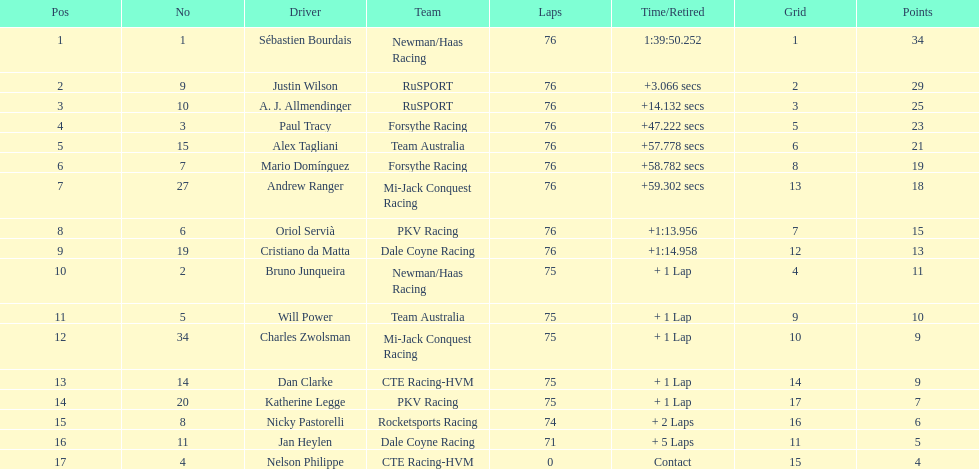Give me the full table as a dictionary. {'header': ['Pos', 'No', 'Driver', 'Team', 'Laps', 'Time/Retired', 'Grid', 'Points'], 'rows': [['1', '1', 'Sébastien Bourdais', 'Newman/Haas Racing', '76', '1:39:50.252', '1', '34'], ['2', '9', 'Justin Wilson', 'RuSPORT', '76', '+3.066 secs', '2', '29'], ['3', '10', 'A. J. Allmendinger', 'RuSPORT', '76', '+14.132 secs', '3', '25'], ['4', '3', 'Paul Tracy', 'Forsythe Racing', '76', '+47.222 secs', '5', '23'], ['5', '15', 'Alex Tagliani', 'Team Australia', '76', '+57.778 secs', '6', '21'], ['6', '7', 'Mario Domínguez', 'Forsythe Racing', '76', '+58.782 secs', '8', '19'], ['7', '27', 'Andrew Ranger', 'Mi-Jack Conquest Racing', '76', '+59.302 secs', '13', '18'], ['8', '6', 'Oriol Servià', 'PKV Racing', '76', '+1:13.956', '7', '15'], ['9', '19', 'Cristiano da Matta', 'Dale Coyne Racing', '76', '+1:14.958', '12', '13'], ['10', '2', 'Bruno Junqueira', 'Newman/Haas Racing', '75', '+ 1 Lap', '4', '11'], ['11', '5', 'Will Power', 'Team Australia', '75', '+ 1 Lap', '9', '10'], ['12', '34', 'Charles Zwolsman', 'Mi-Jack Conquest Racing', '75', '+ 1 Lap', '10', '9'], ['13', '14', 'Dan Clarke', 'CTE Racing-HVM', '75', '+ 1 Lap', '14', '9'], ['14', '20', 'Katherine Legge', 'PKV Racing', '75', '+ 1 Lap', '17', '7'], ['15', '8', 'Nicky Pastorelli', 'Rocketsports Racing', '74', '+ 2 Laps', '16', '6'], ['16', '11', 'Jan Heylen', 'Dale Coyne Racing', '71', '+ 5 Laps', '11', '5'], ['17', '4', 'Nelson Philippe', 'CTE Racing-HVM', '0', 'Contact', '15', '4']]} Which canadian competitor completed first: alex tagliani or paul tracy? Paul Tracy. 